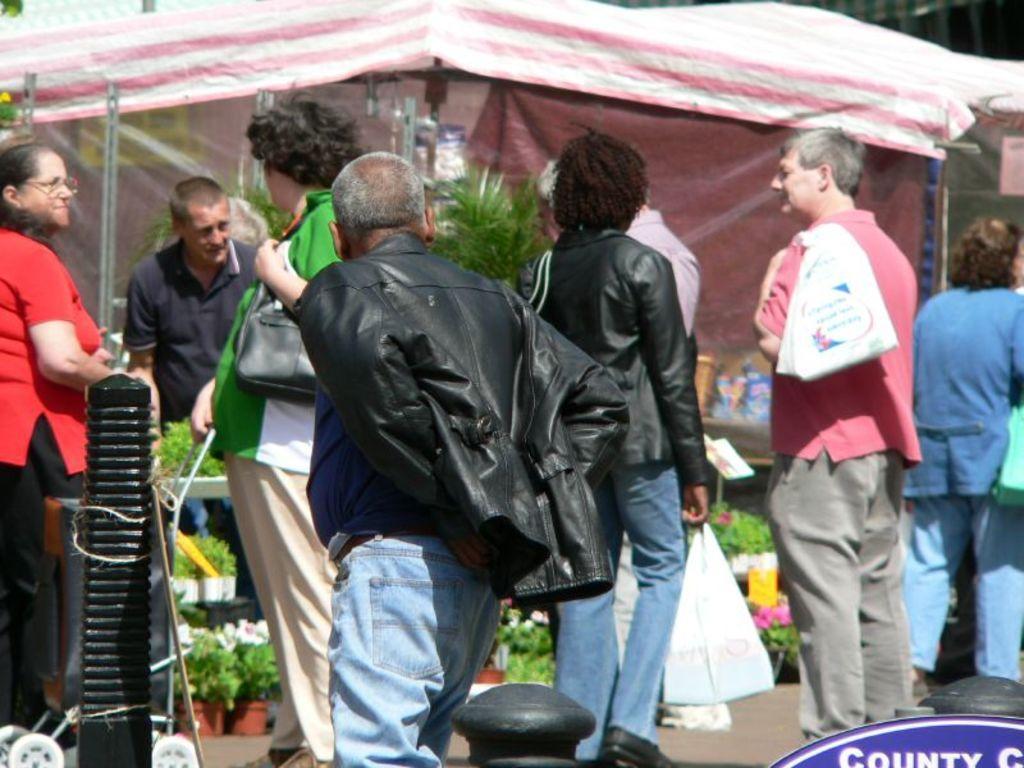Describe this image in one or two sentences. This picture is clicked outside. In the center we can see the group of people seems to be standing on the ground and we can see the bags, potted plants, flowers and we can see the tent and many other objects. In the bottom right corner we can see the watermark on the image. 